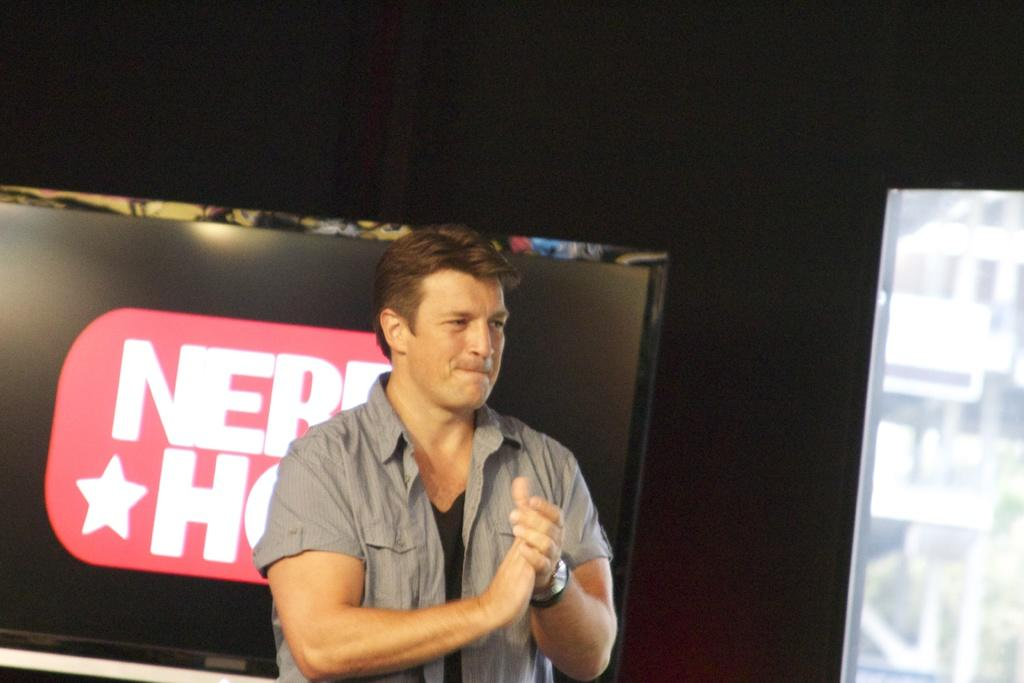Who or what is present in the image? There is a person in the image. What else can be seen in the image besides the person? There is text visible in the image, as well as a television and an object on the right side of the image. What is the color of the background in the image? The background of the image is black. What type of apple is being used as a prop in the image? There is no apple present in the image. What subject is the person in the image paying attention to? The provided facts do not give information about the person's attention or focus in the image. 